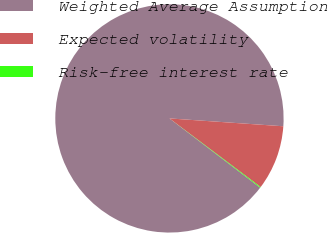Convert chart to OTSL. <chart><loc_0><loc_0><loc_500><loc_500><pie_chart><fcel>Weighted Average Assumption<fcel>Expected volatility<fcel>Risk-free interest rate<nl><fcel>90.72%<fcel>9.17%<fcel>0.11%<nl></chart> 